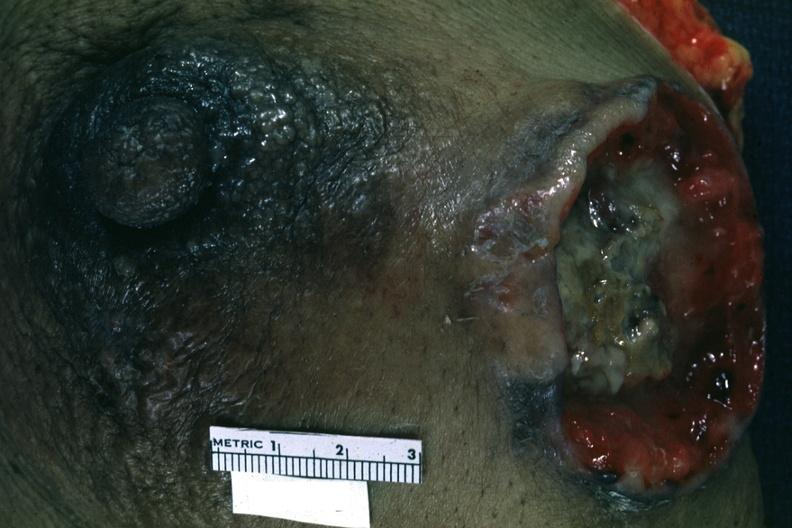how is close-up excised breast with ulcerating carcinoma?
Answer the question using a single word or phrase. Large 